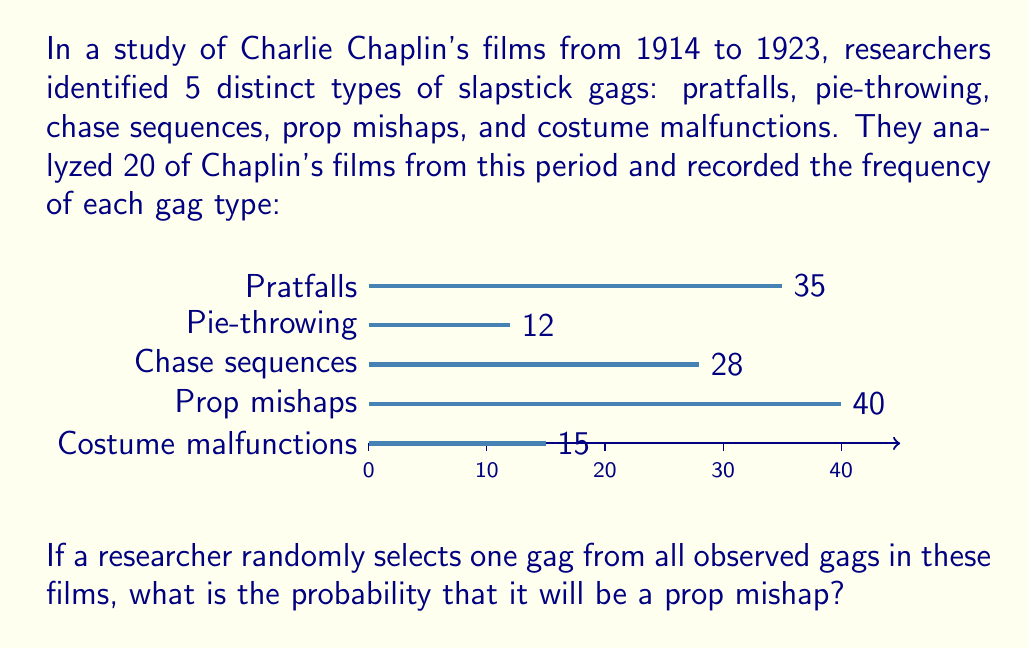Show me your answer to this math problem. To solve this problem, we need to follow these steps:

1) First, we need to calculate the total number of gags observed across all 20 films. We can do this by summing the frequencies of each gag type:

   $35 + 12 + 28 + 40 + 15 = 130$ total gags

2) Now, we need to identify how many of these gags were prop mishaps. From the data given, we can see that there were 40 prop mishaps.

3) The probability of selecting a prop mishap is the number of favorable outcomes (prop mishaps) divided by the total number of possible outcomes (all gags):

   $$P(\text{prop mishap}) = \frac{\text{number of prop mishaps}}{\text{total number of gags}} = \frac{40}{130}$$

4) This fraction can be simplified:
   
   $$\frac{40}{130} = \frac{4}{13} \approx 0.3077$$

Thus, the probability of randomly selecting a prop mishap from all observed gags is $\frac{4}{13}$ or approximately 0.3077 or 30.77%.
Answer: $\frac{4}{13}$ 